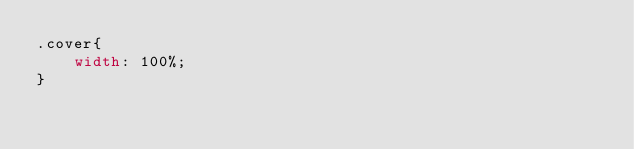Convert code to text. <code><loc_0><loc_0><loc_500><loc_500><_CSS_>.cover{
    width: 100%;
}</code> 